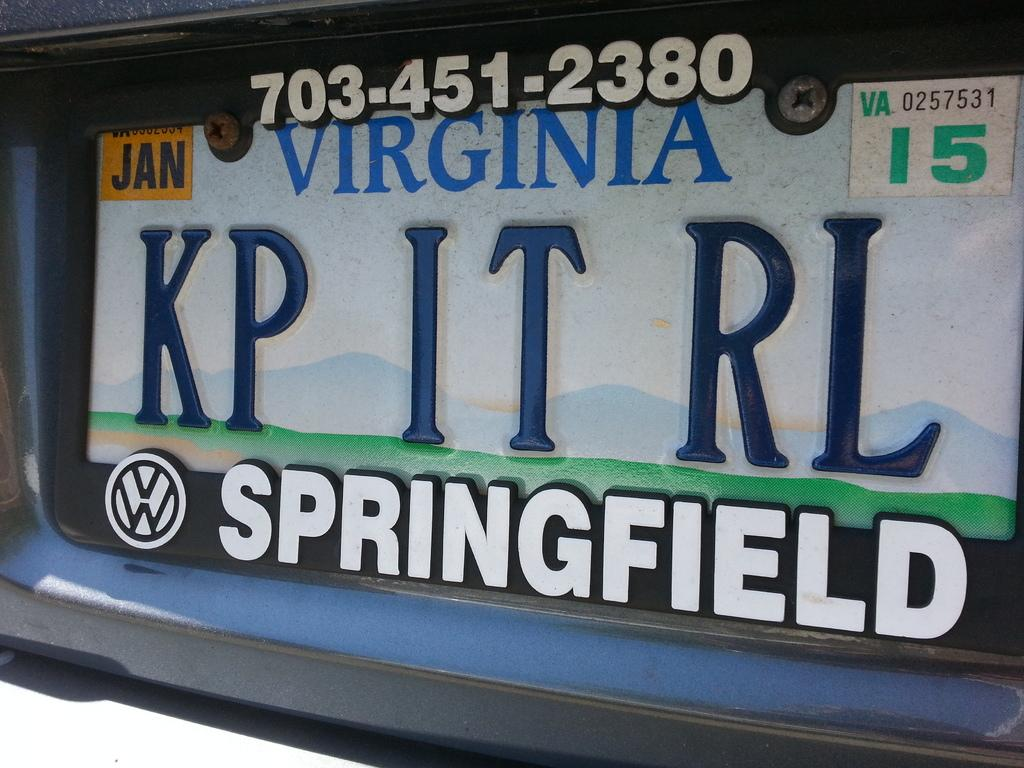<image>
Create a compact narrative representing the image presented. A Volkswagen vehicle has a licenses plate from Virginia. 